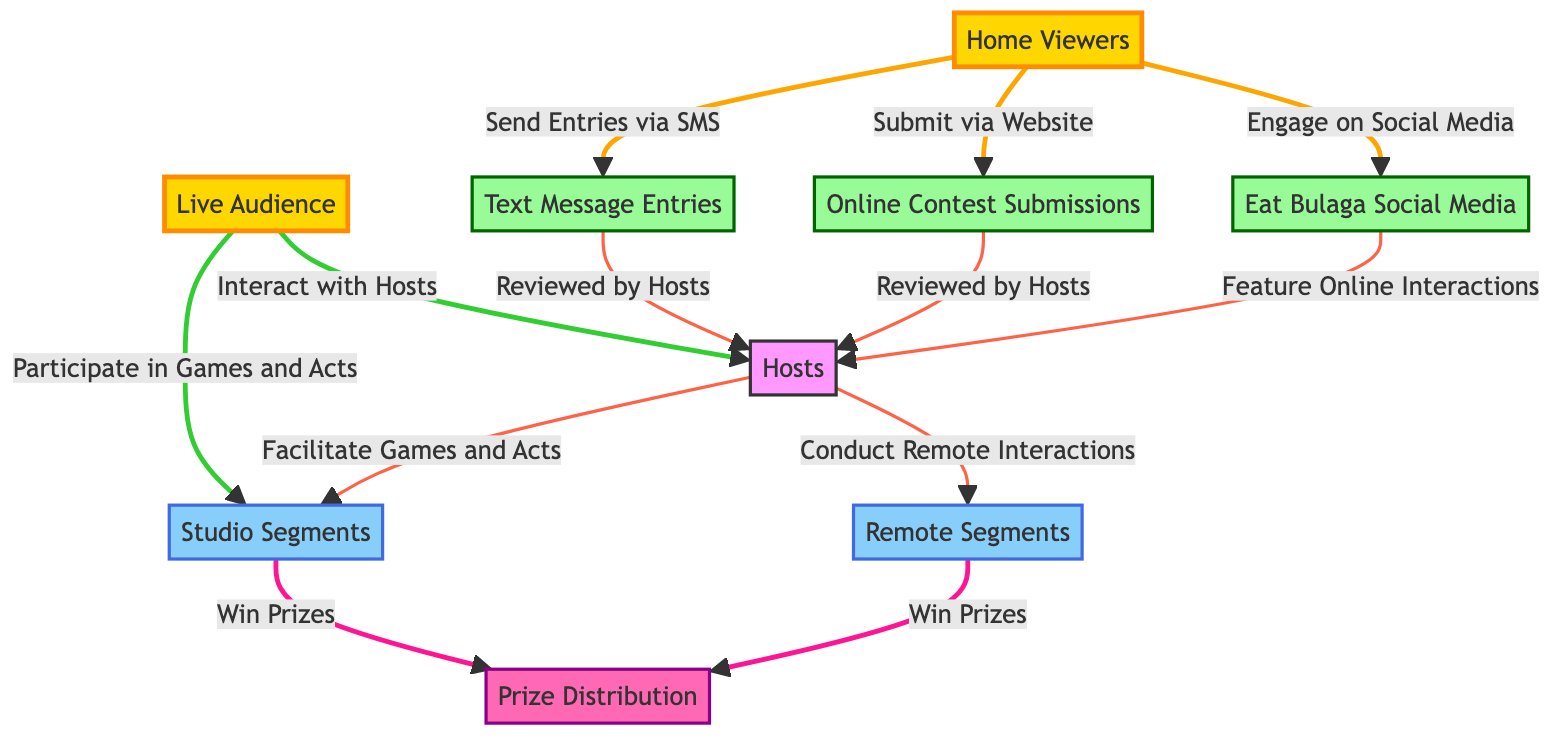What is the total number of nodes in the diagram? The diagram includes nodes representing distinct categories of audience interactions and participation methods: Home Viewers, Live Audience, Hosts, Eat Bulaga Social Media, Text Message Entries, Online Contest Submissions, Studio Segments, Remote Segments, and Prize Distribution. Counting these gives a total of 9 nodes.
Answer: 9 How many edges are present in the diagram? Each interaction or relationship depicted by an arrow represents an edge. By counting all the edges connecting the nodes, there are 12 edges in total.
Answer: 12 Which node represents the audience that participates live? The node labeled "Live Audience" signifies the audience that engages directly with the program while it is being broadcasted.
Answer: Live Audience What method do Home Viewers use to send entries via SMS? The edge indicates that Home Viewers send their entries using Text Message Entries, which is the direct relationship connecting them.
Answer: Send Entries via SMS Who facilitates games and acts during the studio segments? The Hosts node is connected to Studio Segments through an edge labeled "Facilitate Games and Acts," indicating that the hosts are responsible for this role during these segments.
Answer: Hosts What do both Studio Segments and Remote Segments lead to? An arrow labeled "Win Prizes" indicates that both the Studio Segments and Remote Segments result in Prize Distribution. Thus, both categories contribute to the opportunity to win prizes.
Answer: Prize Distribution How do Home Viewers engage with the show on social media? The edge from Home Viewers to Eat Bulaga Social Media shows that they engage by featuring their interactions online, which is described as "Engage on Social Media."
Answer: Engage on Social Media What type of entries do Home Viewers submit via the website? The edge from Home Viewers to Online Contest Submissions indicates that Home Viewers submit their entries through this platform, as specified in the relationship.
Answer: Submit via Website In what way do Live Audience members interact with the Hosts? The edge shows that Live Audience members can "Interact with Hosts," indicating a direct participatory method during the program.
Answer: Interact with Hosts 